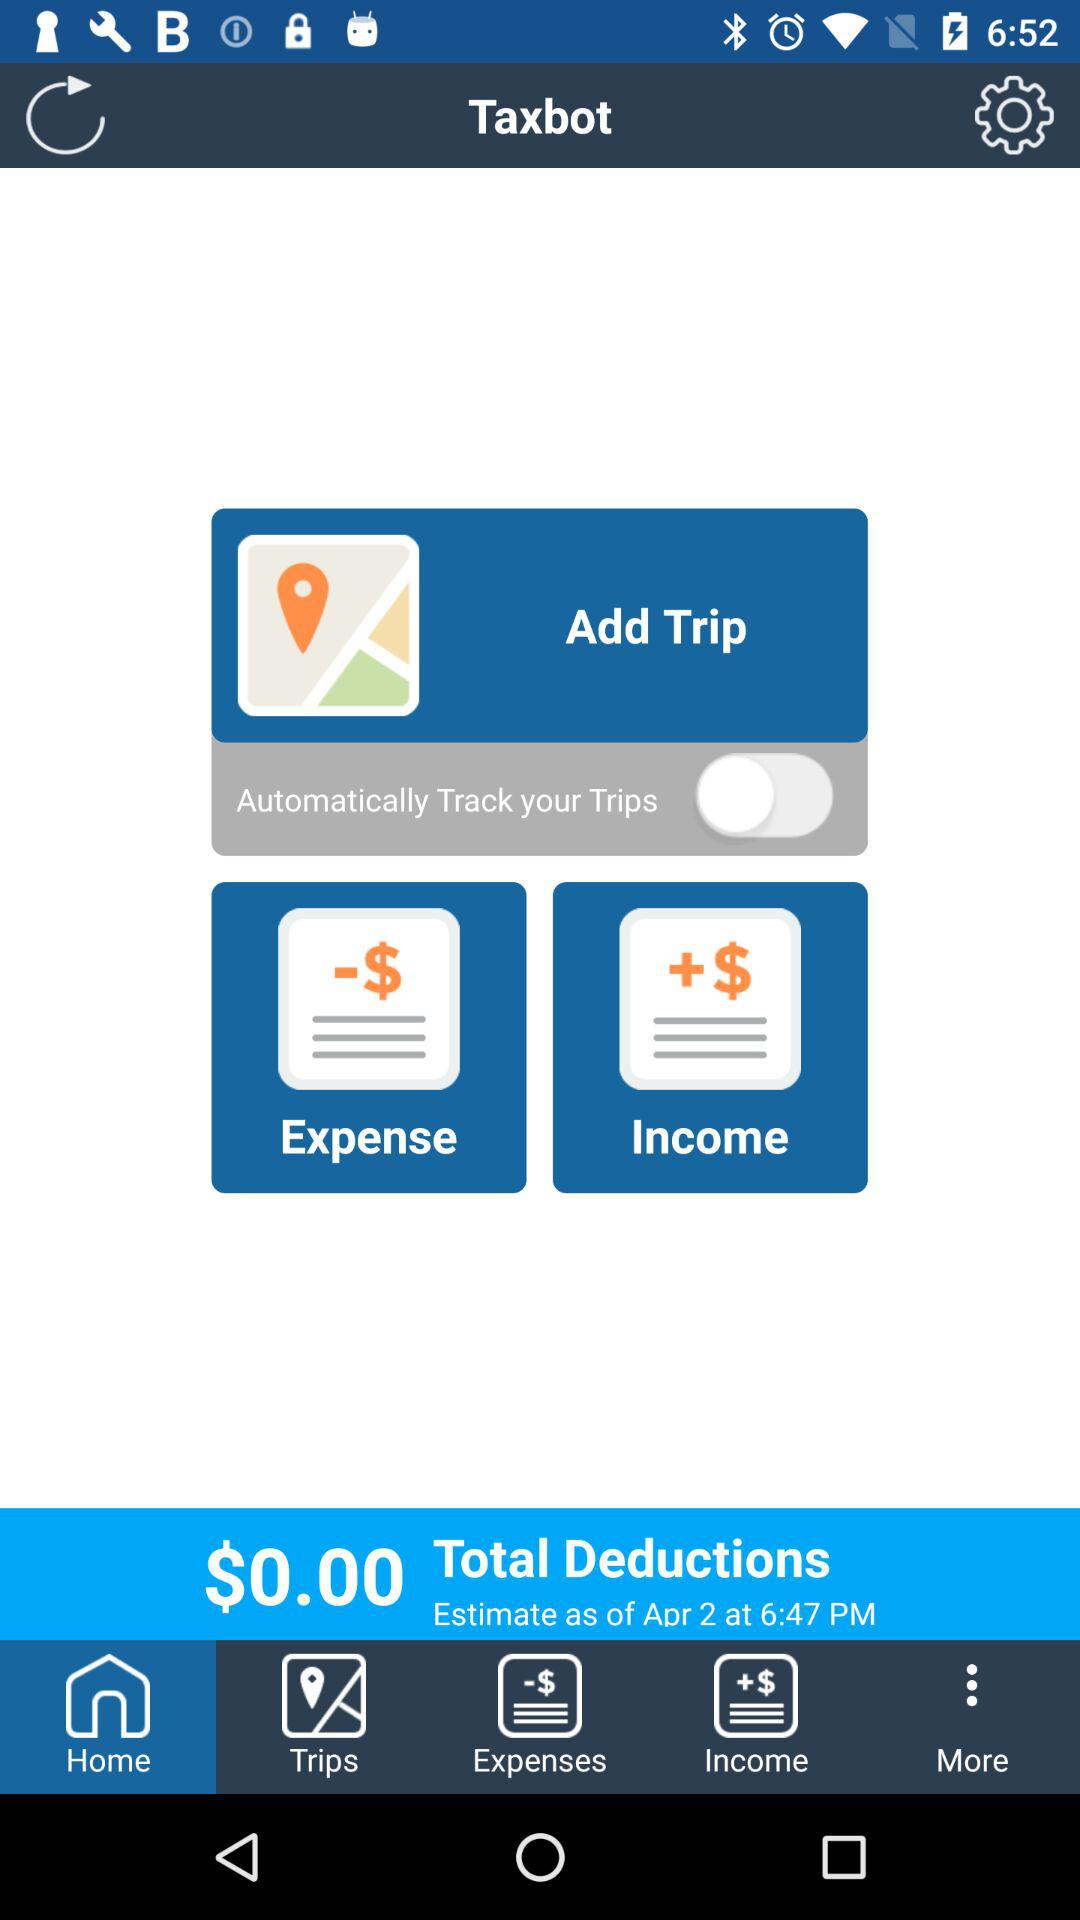How much is the total deduction?
Answer the question using a single word or phrase. $0.00 